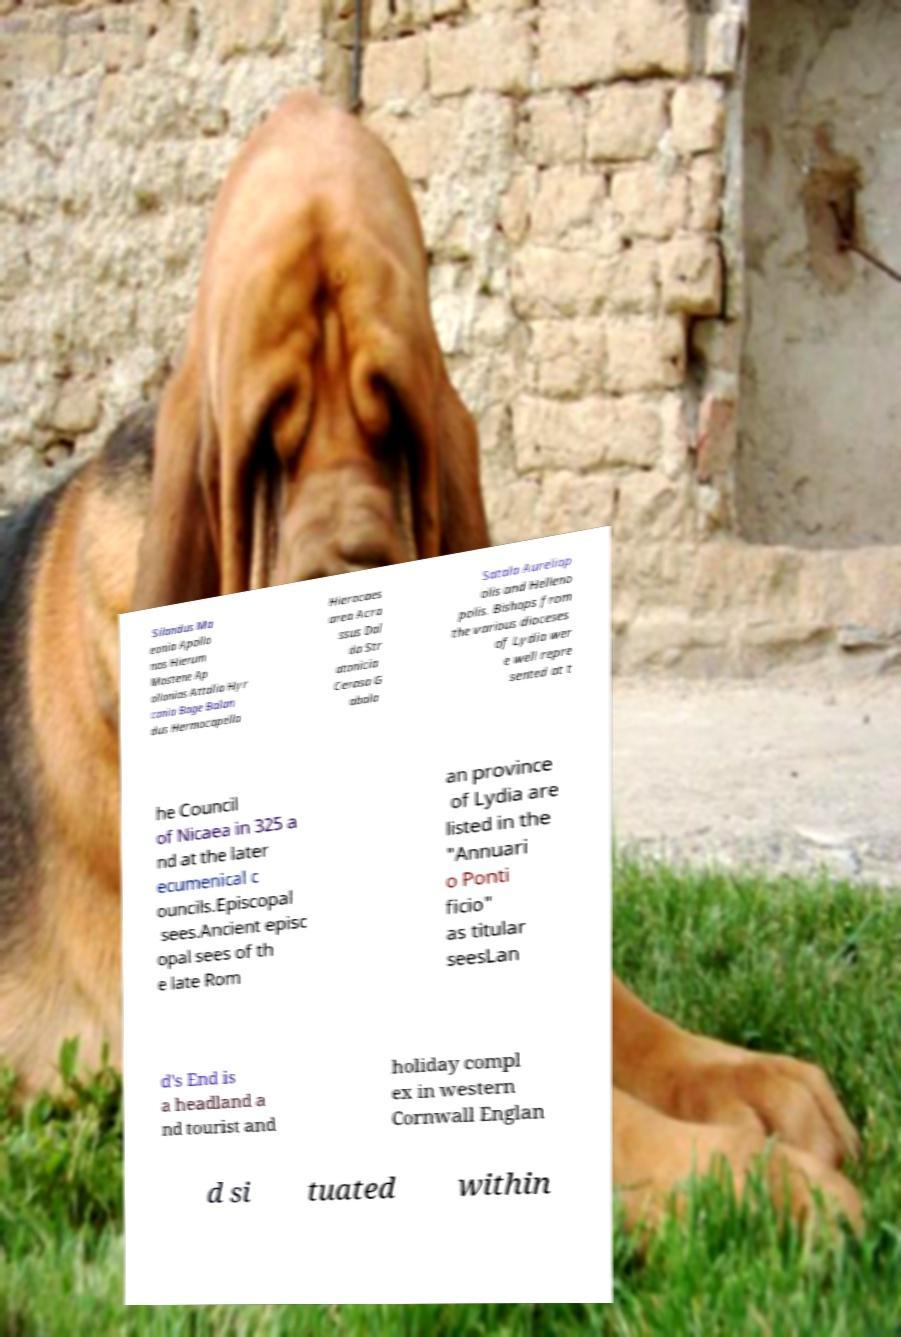What messages or text are displayed in this image? I need them in a readable, typed format. Silandus Ma eonia Apollo nos Hierum Mostene Ap ollonias Attalia Hyr cania Bage Balan dus Hermocapella Hierocaes area Acra ssus Dal da Str atonicia Cerasa G abala Satala Aureliop olis and Helleno polis. Bishops from the various dioceses of Lydia wer e well repre sented at t he Council of Nicaea in 325 a nd at the later ecumenical c ouncils.Episcopal sees.Ancient episc opal sees of th e late Rom an province of Lydia are listed in the "Annuari o Ponti ficio" as titular seesLan d's End is a headland a nd tourist and holiday compl ex in western Cornwall Englan d si tuated within 